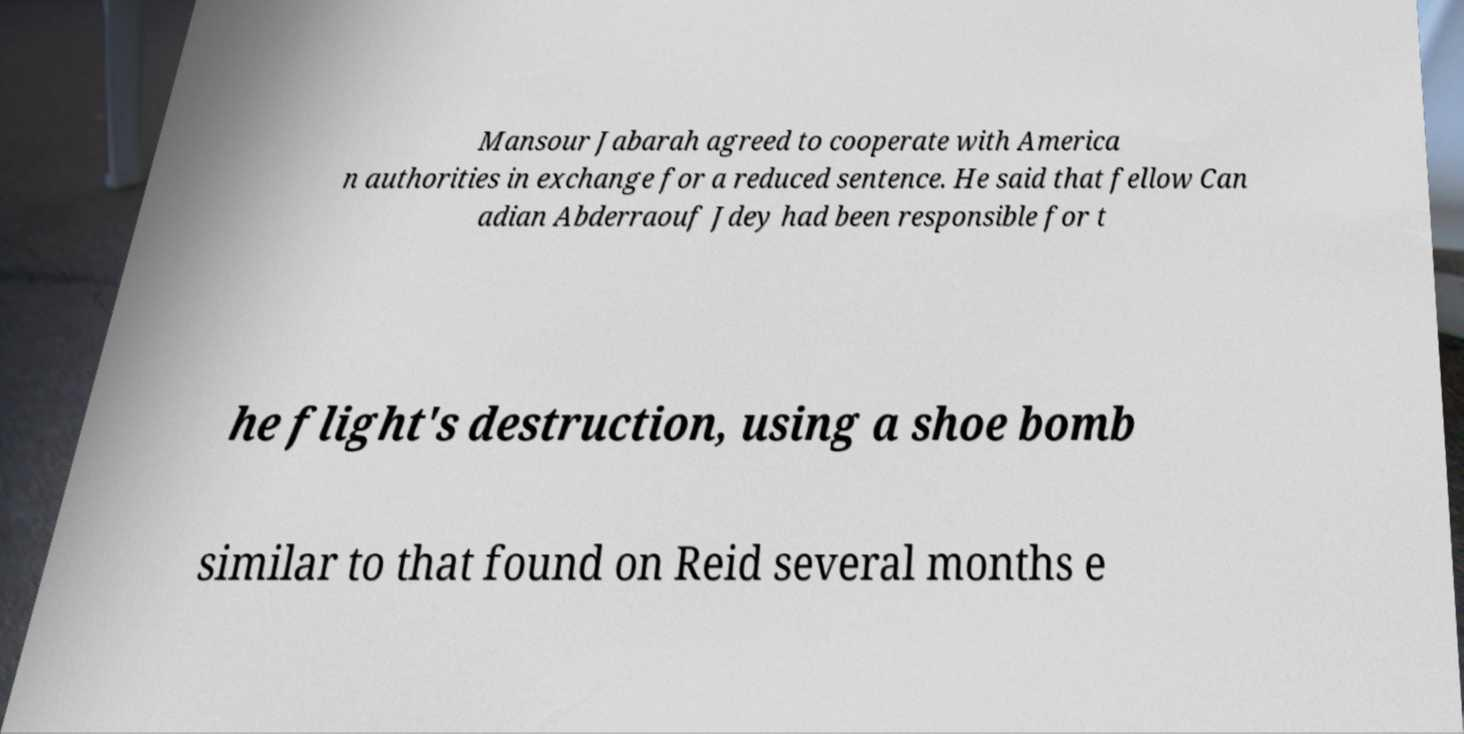Please read and relay the text visible in this image. What does it say? Mansour Jabarah agreed to cooperate with America n authorities in exchange for a reduced sentence. He said that fellow Can adian Abderraouf Jdey had been responsible for t he flight's destruction, using a shoe bomb similar to that found on Reid several months e 